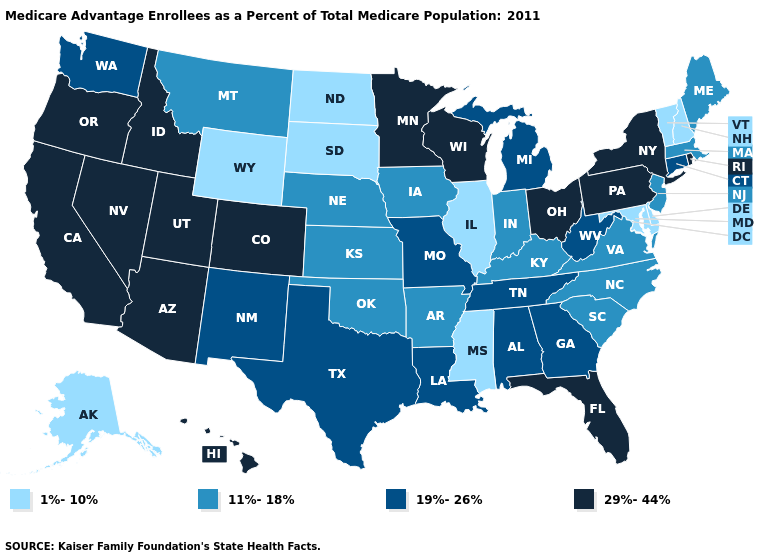Does Utah have the highest value in the USA?
Concise answer only. Yes. Name the states that have a value in the range 1%-10%?
Keep it brief. Alaska, Delaware, Illinois, Maryland, Mississippi, North Dakota, New Hampshire, South Dakota, Vermont, Wyoming. What is the lowest value in the USA?
Quick response, please. 1%-10%. Name the states that have a value in the range 11%-18%?
Answer briefly. Arkansas, Iowa, Indiana, Kansas, Kentucky, Massachusetts, Maine, Montana, North Carolina, Nebraska, New Jersey, Oklahoma, South Carolina, Virginia. Among the states that border Utah , which have the lowest value?
Answer briefly. Wyoming. Among the states that border Georgia , does Florida have the highest value?
Concise answer only. Yes. Does the first symbol in the legend represent the smallest category?
Concise answer only. Yes. Does Alabama have a higher value than Oklahoma?
Be succinct. Yes. Name the states that have a value in the range 19%-26%?
Short answer required. Alabama, Connecticut, Georgia, Louisiana, Michigan, Missouri, New Mexico, Tennessee, Texas, Washington, West Virginia. What is the value of Nebraska?
Write a very short answer. 11%-18%. What is the value of Pennsylvania?
Be succinct. 29%-44%. Which states have the highest value in the USA?
Give a very brief answer. Arizona, California, Colorado, Florida, Hawaii, Idaho, Minnesota, Nevada, New York, Ohio, Oregon, Pennsylvania, Rhode Island, Utah, Wisconsin. What is the value of Iowa?
Keep it brief. 11%-18%. What is the value of Louisiana?
Short answer required. 19%-26%. Among the states that border Alabama , which have the highest value?
Be succinct. Florida. 